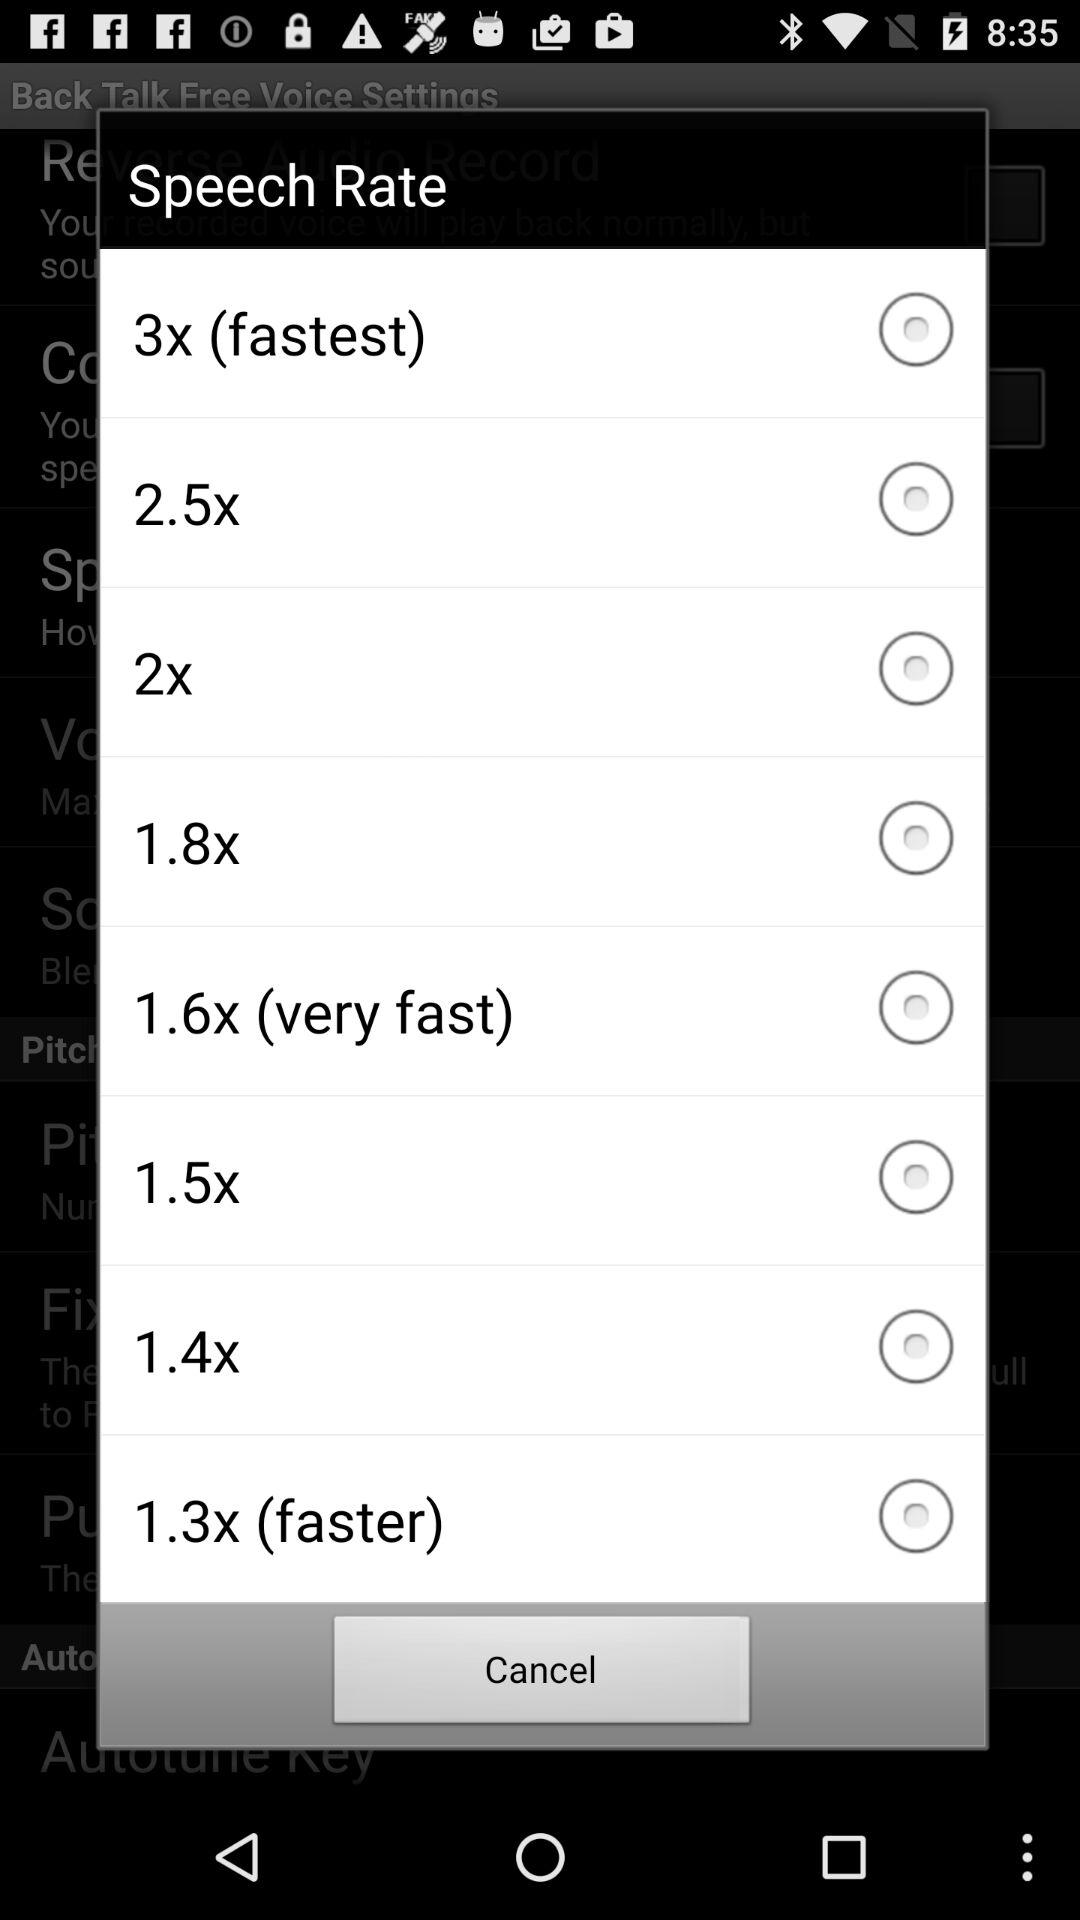Is "3x" selected or not? "3x" is not selected. 